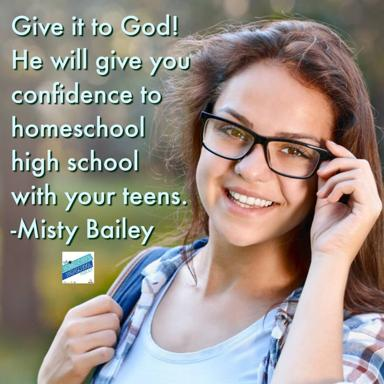What are some challenges of homeschooling high school students? Homeschooling high school students can present several challenges, including the need for a structured curriculum, preparing for college admissions, and ensuring socialization opportunities. It also demands a great deal of patience and resourcefulness from parents to meet these diverse needs effectively. 